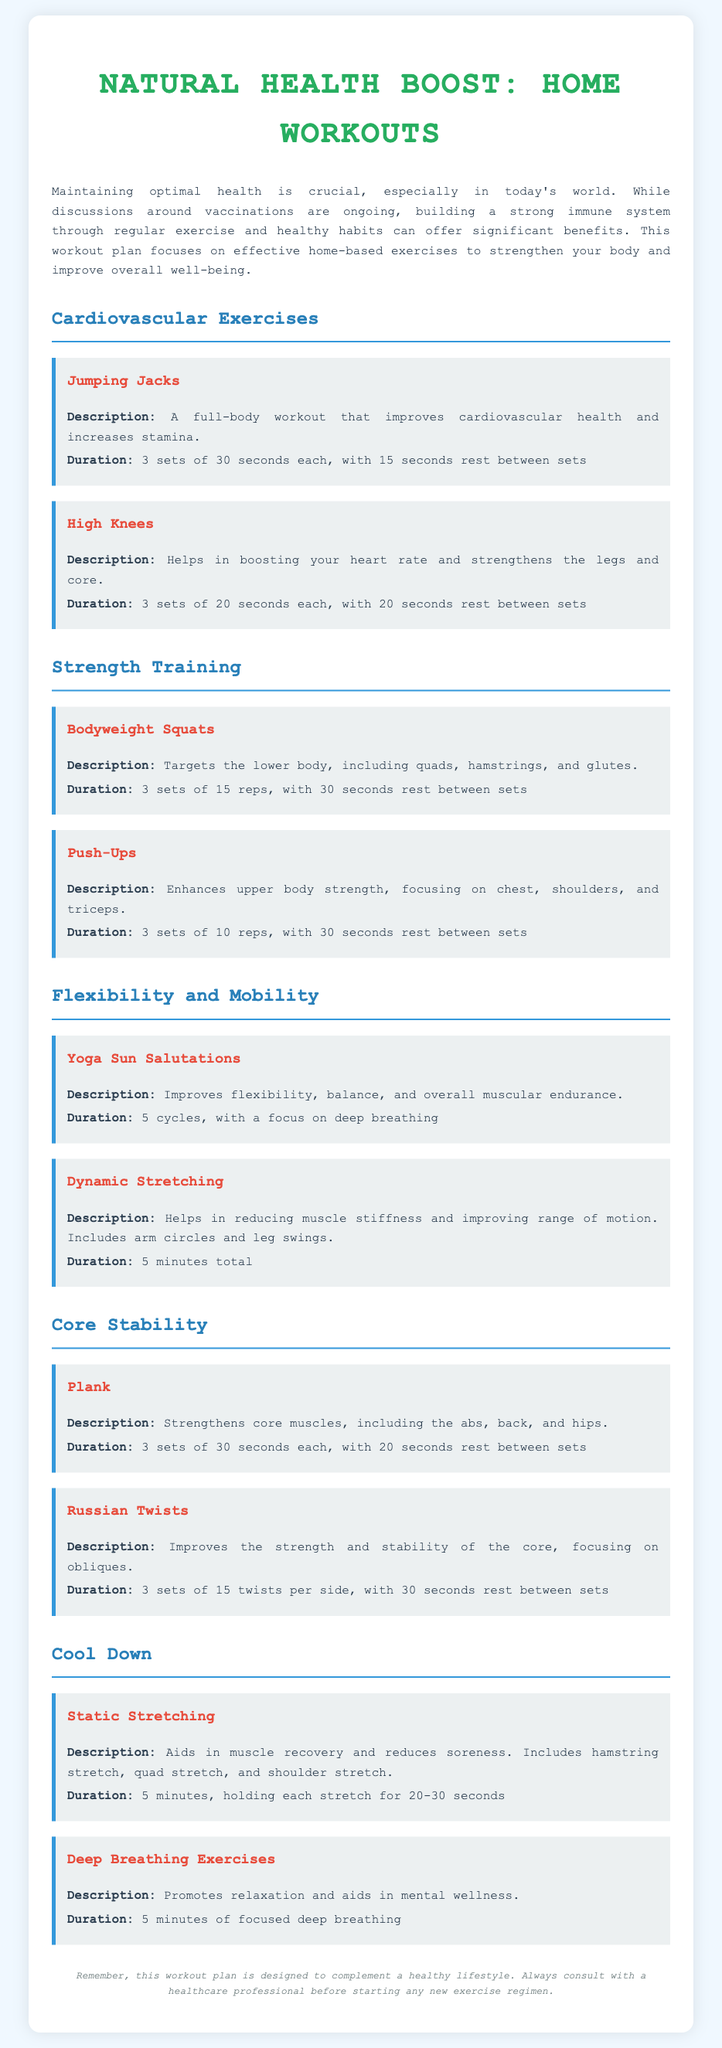what is the title of the document? The title of the document is explicitly mentioned in the header as "Natural Health Boost: Home Workouts."
Answer: Natural Health Boost: Home Workouts how many sets are recommended for Jumping Jacks? The document specifies that Jumping Jacks should be performed in 3 sets of 30 seconds each.
Answer: 3 sets what type of exercise is recommended for flexibility? The document mentions "Yoga Sun Salutations" and "Dynamic Stretching" under the flexibility section.
Answer: Yoga Sun Salutations what is the duration for bodyweight squats? According to the workout plan, bodyweight squats are recommended for 3 sets of 15 reps, with 30 seconds rest between sets.
Answer: 3 sets of 15 reps what exercise is suggested to strengthen the core? The document recommends both "Plank" and "Russian Twists" as exercises to strengthen the core.
Answer: Plank how long should static stretching be held for? The document states that each static stretch should be held for 20-30 seconds during the cool-down.
Answer: 20-30 seconds what is the duration for deep breathing exercises? The document recommends a duration of 5 minutes for deep breathing exercises.
Answer: 5 minutes which exercise focuses on the legs and core? The document highlights "High Knees" as an exercise that boosts heart rate and strengthens the legs and core.
Answer: High Knees what is the primary focus of Push-Ups? According to the document, Push-Ups enhance upper body strength, focusing on chest, shoulders, and triceps.
Answer: Upper body strength 